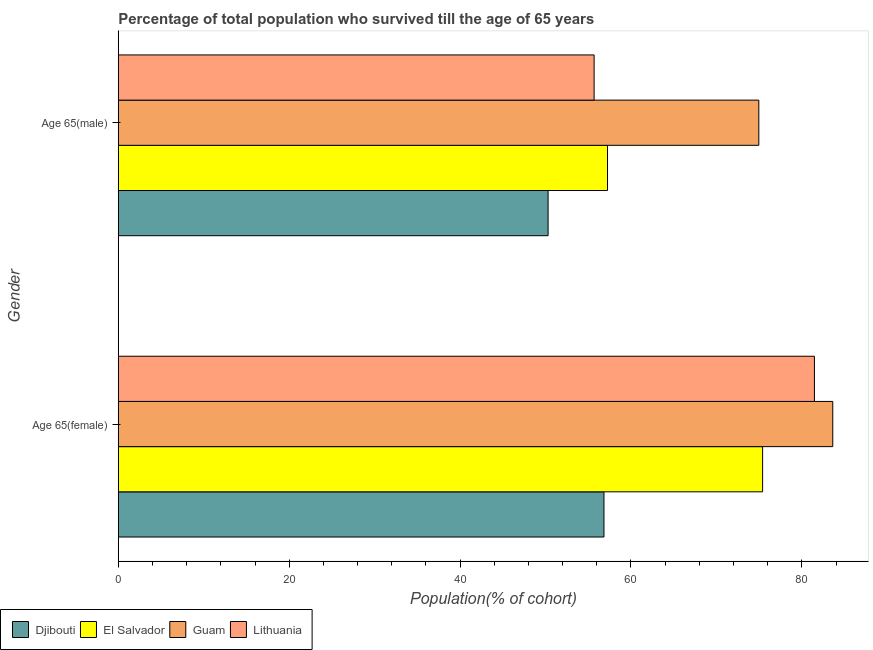How many groups of bars are there?
Ensure brevity in your answer.  2. Are the number of bars per tick equal to the number of legend labels?
Keep it short and to the point. Yes. Are the number of bars on each tick of the Y-axis equal?
Your response must be concise. Yes. How many bars are there on the 2nd tick from the bottom?
Make the answer very short. 4. What is the label of the 2nd group of bars from the top?
Ensure brevity in your answer.  Age 65(female). What is the percentage of male population who survived till age of 65 in Djibouti?
Your answer should be very brief. 50.3. Across all countries, what is the maximum percentage of female population who survived till age of 65?
Give a very brief answer. 83.62. Across all countries, what is the minimum percentage of male population who survived till age of 65?
Offer a very short reply. 50.3. In which country was the percentage of male population who survived till age of 65 maximum?
Your answer should be compact. Guam. In which country was the percentage of male population who survived till age of 65 minimum?
Ensure brevity in your answer.  Djibouti. What is the total percentage of male population who survived till age of 65 in the graph?
Ensure brevity in your answer.  238.22. What is the difference between the percentage of female population who survived till age of 65 in Lithuania and that in Guam?
Offer a terse response. -2.15. What is the difference between the percentage of female population who survived till age of 65 in El Salvador and the percentage of male population who survived till age of 65 in Lithuania?
Keep it short and to the point. 19.72. What is the average percentage of male population who survived till age of 65 per country?
Your answer should be very brief. 59.55. What is the difference between the percentage of male population who survived till age of 65 and percentage of female population who survived till age of 65 in Djibouti?
Keep it short and to the point. -6.54. What is the ratio of the percentage of male population who survived till age of 65 in Djibouti to that in Lithuania?
Your answer should be very brief. 0.9. Is the percentage of female population who survived till age of 65 in Lithuania less than that in Guam?
Your answer should be very brief. Yes. What does the 1st bar from the top in Age 65(male) represents?
Offer a terse response. Lithuania. What does the 4th bar from the bottom in Age 65(male) represents?
Make the answer very short. Lithuania. How many bars are there?
Your answer should be very brief. 8. How many countries are there in the graph?
Your answer should be very brief. 4. What is the difference between two consecutive major ticks on the X-axis?
Your response must be concise. 20. Does the graph contain any zero values?
Offer a terse response. No. Does the graph contain grids?
Keep it short and to the point. No. Where does the legend appear in the graph?
Offer a terse response. Bottom left. How many legend labels are there?
Make the answer very short. 4. How are the legend labels stacked?
Provide a short and direct response. Horizontal. What is the title of the graph?
Keep it short and to the point. Percentage of total population who survived till the age of 65 years. What is the label or title of the X-axis?
Your response must be concise. Population(% of cohort). What is the label or title of the Y-axis?
Provide a succinct answer. Gender. What is the Population(% of cohort) in Djibouti in Age 65(female)?
Give a very brief answer. 56.84. What is the Population(% of cohort) of El Salvador in Age 65(female)?
Offer a very short reply. 75.41. What is the Population(% of cohort) in Guam in Age 65(female)?
Your answer should be very brief. 83.62. What is the Population(% of cohort) in Lithuania in Age 65(female)?
Provide a short and direct response. 81.47. What is the Population(% of cohort) of Djibouti in Age 65(male)?
Give a very brief answer. 50.3. What is the Population(% of cohort) in El Salvador in Age 65(male)?
Your answer should be compact. 57.26. What is the Population(% of cohort) of Guam in Age 65(male)?
Your response must be concise. 74.97. What is the Population(% of cohort) in Lithuania in Age 65(male)?
Keep it short and to the point. 55.69. Across all Gender, what is the maximum Population(% of cohort) in Djibouti?
Offer a very short reply. 56.84. Across all Gender, what is the maximum Population(% of cohort) of El Salvador?
Your answer should be very brief. 75.41. Across all Gender, what is the maximum Population(% of cohort) in Guam?
Your response must be concise. 83.62. Across all Gender, what is the maximum Population(% of cohort) in Lithuania?
Provide a short and direct response. 81.47. Across all Gender, what is the minimum Population(% of cohort) in Djibouti?
Make the answer very short. 50.3. Across all Gender, what is the minimum Population(% of cohort) of El Salvador?
Ensure brevity in your answer.  57.26. Across all Gender, what is the minimum Population(% of cohort) of Guam?
Provide a succinct answer. 74.97. Across all Gender, what is the minimum Population(% of cohort) in Lithuania?
Provide a short and direct response. 55.69. What is the total Population(% of cohort) of Djibouti in the graph?
Your response must be concise. 107.15. What is the total Population(% of cohort) of El Salvador in the graph?
Offer a very short reply. 132.67. What is the total Population(% of cohort) of Guam in the graph?
Ensure brevity in your answer.  158.59. What is the total Population(% of cohort) of Lithuania in the graph?
Provide a short and direct response. 137.16. What is the difference between the Population(% of cohort) of Djibouti in Age 65(female) and that in Age 65(male)?
Your answer should be very brief. 6.54. What is the difference between the Population(% of cohort) of El Salvador in Age 65(female) and that in Age 65(male)?
Give a very brief answer. 18.15. What is the difference between the Population(% of cohort) in Guam in Age 65(female) and that in Age 65(male)?
Make the answer very short. 8.65. What is the difference between the Population(% of cohort) of Lithuania in Age 65(female) and that in Age 65(male)?
Make the answer very short. 25.78. What is the difference between the Population(% of cohort) of Djibouti in Age 65(female) and the Population(% of cohort) of El Salvador in Age 65(male)?
Make the answer very short. -0.41. What is the difference between the Population(% of cohort) in Djibouti in Age 65(female) and the Population(% of cohort) in Guam in Age 65(male)?
Your response must be concise. -18.12. What is the difference between the Population(% of cohort) in Djibouti in Age 65(female) and the Population(% of cohort) in Lithuania in Age 65(male)?
Your answer should be compact. 1.15. What is the difference between the Population(% of cohort) of El Salvador in Age 65(female) and the Population(% of cohort) of Guam in Age 65(male)?
Give a very brief answer. 0.44. What is the difference between the Population(% of cohort) in El Salvador in Age 65(female) and the Population(% of cohort) in Lithuania in Age 65(male)?
Make the answer very short. 19.72. What is the difference between the Population(% of cohort) in Guam in Age 65(female) and the Population(% of cohort) in Lithuania in Age 65(male)?
Your answer should be very brief. 27.93. What is the average Population(% of cohort) in Djibouti per Gender?
Your answer should be very brief. 53.57. What is the average Population(% of cohort) in El Salvador per Gender?
Provide a short and direct response. 66.33. What is the average Population(% of cohort) of Guam per Gender?
Provide a succinct answer. 79.29. What is the average Population(% of cohort) of Lithuania per Gender?
Your answer should be very brief. 68.58. What is the difference between the Population(% of cohort) of Djibouti and Population(% of cohort) of El Salvador in Age 65(female)?
Make the answer very short. -18.57. What is the difference between the Population(% of cohort) of Djibouti and Population(% of cohort) of Guam in Age 65(female)?
Keep it short and to the point. -26.78. What is the difference between the Population(% of cohort) in Djibouti and Population(% of cohort) in Lithuania in Age 65(female)?
Ensure brevity in your answer.  -24.63. What is the difference between the Population(% of cohort) in El Salvador and Population(% of cohort) in Guam in Age 65(female)?
Ensure brevity in your answer.  -8.21. What is the difference between the Population(% of cohort) in El Salvador and Population(% of cohort) in Lithuania in Age 65(female)?
Offer a very short reply. -6.06. What is the difference between the Population(% of cohort) in Guam and Population(% of cohort) in Lithuania in Age 65(female)?
Ensure brevity in your answer.  2.15. What is the difference between the Population(% of cohort) in Djibouti and Population(% of cohort) in El Salvador in Age 65(male)?
Ensure brevity in your answer.  -6.95. What is the difference between the Population(% of cohort) of Djibouti and Population(% of cohort) of Guam in Age 65(male)?
Make the answer very short. -24.66. What is the difference between the Population(% of cohort) in Djibouti and Population(% of cohort) in Lithuania in Age 65(male)?
Your answer should be very brief. -5.39. What is the difference between the Population(% of cohort) of El Salvador and Population(% of cohort) of Guam in Age 65(male)?
Give a very brief answer. -17.71. What is the difference between the Population(% of cohort) in El Salvador and Population(% of cohort) in Lithuania in Age 65(male)?
Your answer should be compact. 1.57. What is the difference between the Population(% of cohort) of Guam and Population(% of cohort) of Lithuania in Age 65(male)?
Provide a short and direct response. 19.28. What is the ratio of the Population(% of cohort) of Djibouti in Age 65(female) to that in Age 65(male)?
Give a very brief answer. 1.13. What is the ratio of the Population(% of cohort) of El Salvador in Age 65(female) to that in Age 65(male)?
Your answer should be compact. 1.32. What is the ratio of the Population(% of cohort) in Guam in Age 65(female) to that in Age 65(male)?
Give a very brief answer. 1.12. What is the ratio of the Population(% of cohort) of Lithuania in Age 65(female) to that in Age 65(male)?
Give a very brief answer. 1.46. What is the difference between the highest and the second highest Population(% of cohort) in Djibouti?
Ensure brevity in your answer.  6.54. What is the difference between the highest and the second highest Population(% of cohort) in El Salvador?
Your answer should be very brief. 18.15. What is the difference between the highest and the second highest Population(% of cohort) in Guam?
Provide a succinct answer. 8.65. What is the difference between the highest and the second highest Population(% of cohort) in Lithuania?
Provide a succinct answer. 25.78. What is the difference between the highest and the lowest Population(% of cohort) of Djibouti?
Offer a very short reply. 6.54. What is the difference between the highest and the lowest Population(% of cohort) in El Salvador?
Ensure brevity in your answer.  18.15. What is the difference between the highest and the lowest Population(% of cohort) in Guam?
Give a very brief answer. 8.65. What is the difference between the highest and the lowest Population(% of cohort) of Lithuania?
Ensure brevity in your answer.  25.78. 